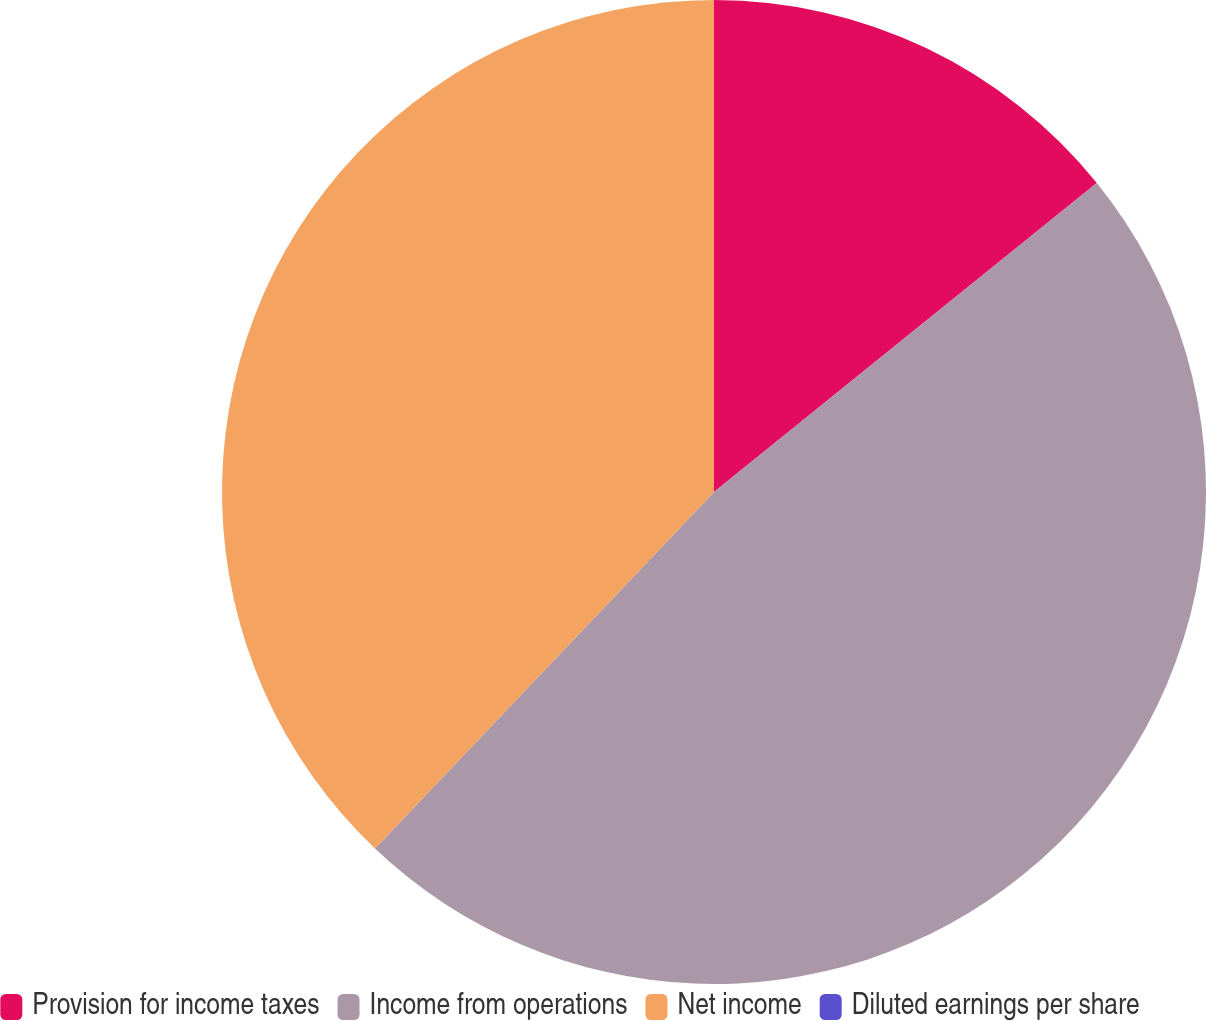<chart> <loc_0><loc_0><loc_500><loc_500><pie_chart><fcel>Provision for income taxes<fcel>Income from operations<fcel>Net income<fcel>Diluted earnings per share<nl><fcel>14.19%<fcel>47.91%<fcel>37.9%<fcel>0.0%<nl></chart> 